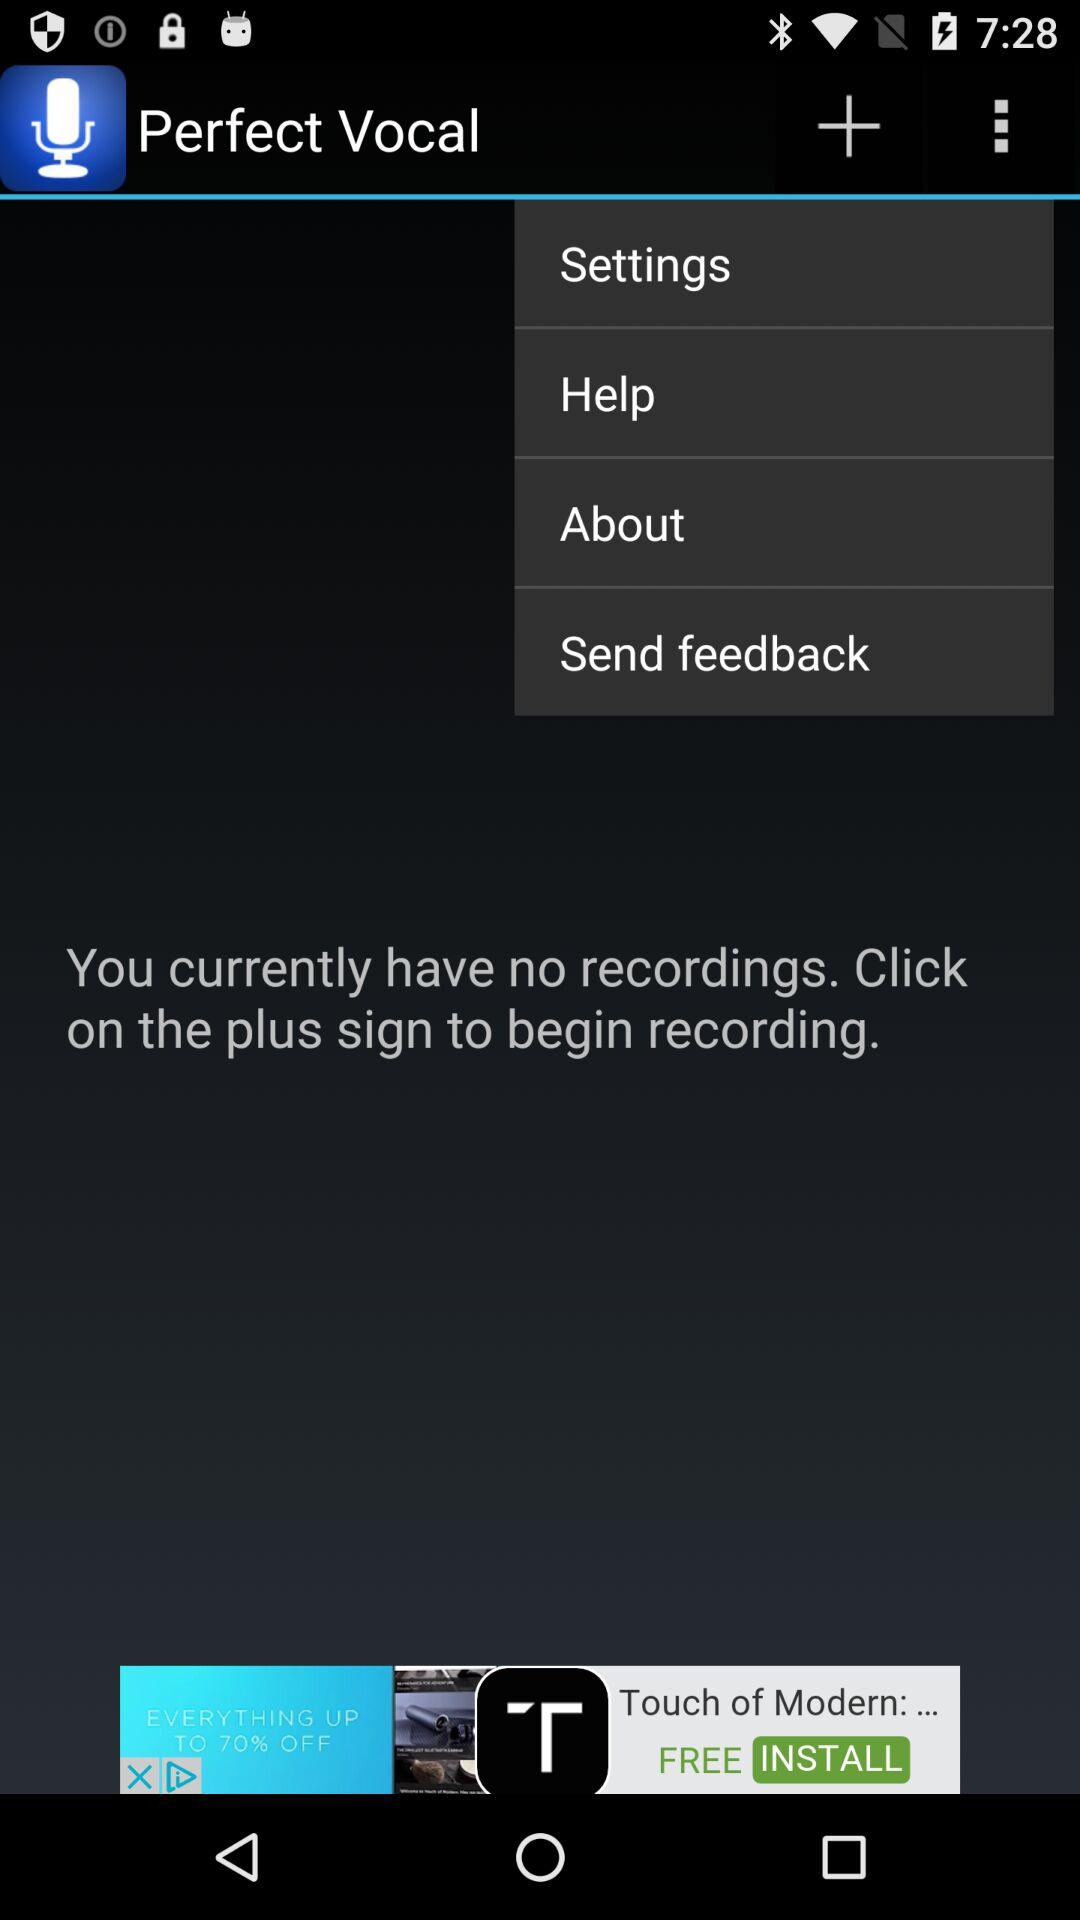What is the application name? The application name is "Perfect Vocal". 